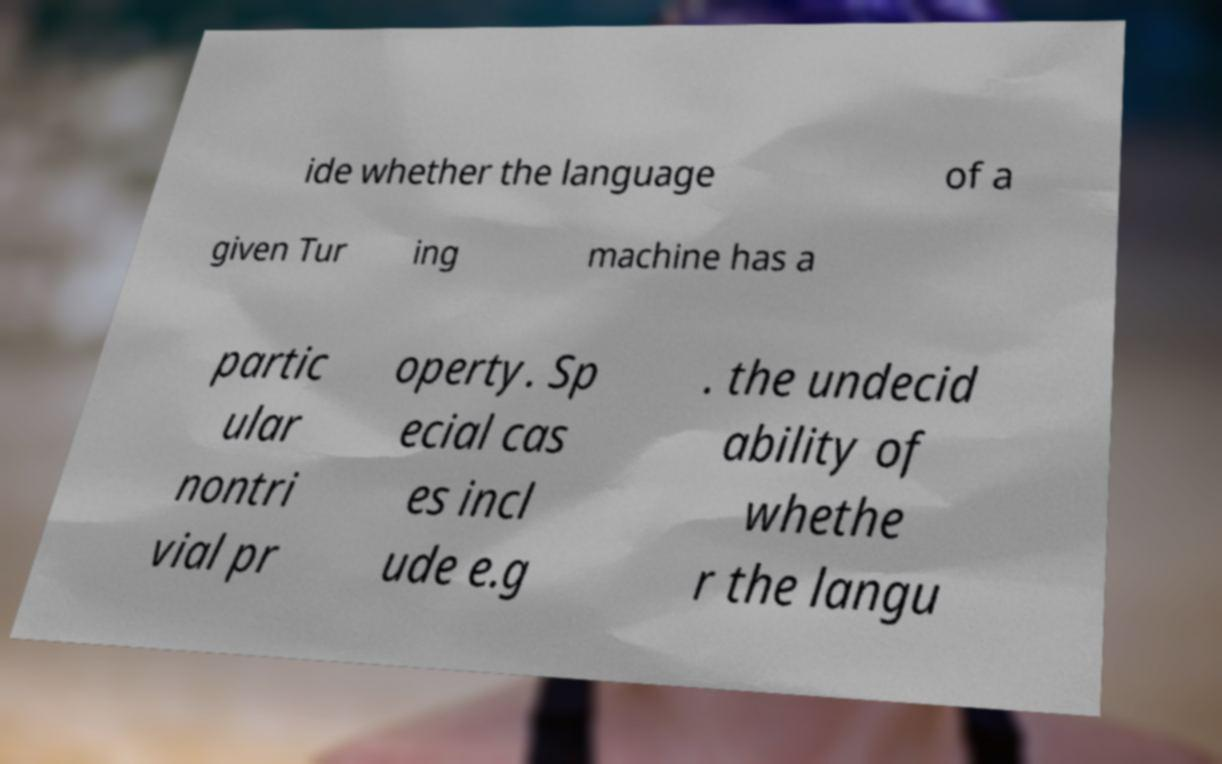Could you extract and type out the text from this image? ide whether the language of a given Tur ing machine has a partic ular nontri vial pr operty. Sp ecial cas es incl ude e.g . the undecid ability of whethe r the langu 